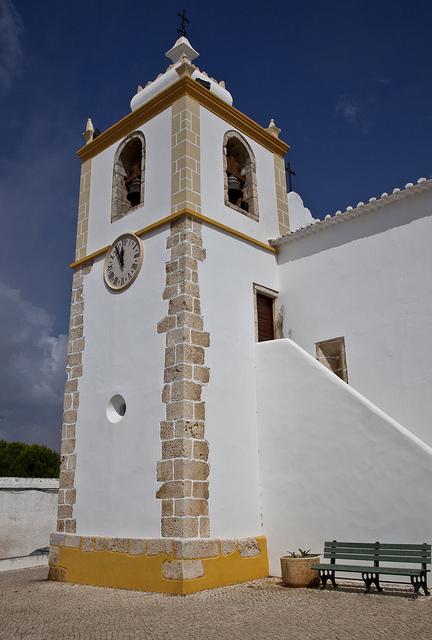Where is the clock?
Quick response, please. On tower. What culture has influenced this architecture?
Keep it brief. Mexican. Does the yellow color at the base of the building look funny?
Be succinct. Yes. 